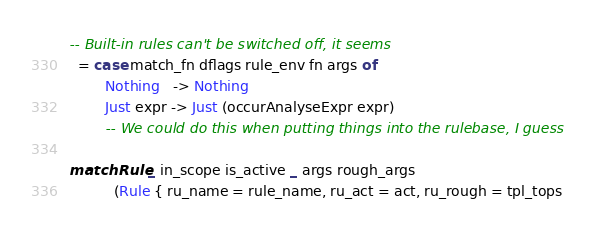Convert code to text. <code><loc_0><loc_0><loc_500><loc_500><_Haskell_>-- Built-in rules can't be switched off, it seems
  = case match_fn dflags rule_env fn args of
        Nothing   -> Nothing
        Just expr -> Just (occurAnalyseExpr expr)
        -- We could do this when putting things into the rulebase, I guess

matchRule _ in_scope is_active _ args rough_args
          (Rule { ru_name = rule_name, ru_act = act, ru_rough = tpl_tops</code> 